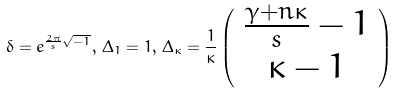Convert formula to latex. <formula><loc_0><loc_0><loc_500><loc_500>\delta = e ^ { { \frac { 2 \pi } { s } } \sqrt { - 1 } } , \, \Delta _ { 1 } = 1 , \, \Delta _ { \kappa } = \frac { 1 } { \kappa } \left ( \begin{array} { c } \frac { \gamma + n \kappa } { s } - 1 \\ \kappa - 1 \end{array} \right )</formula> 